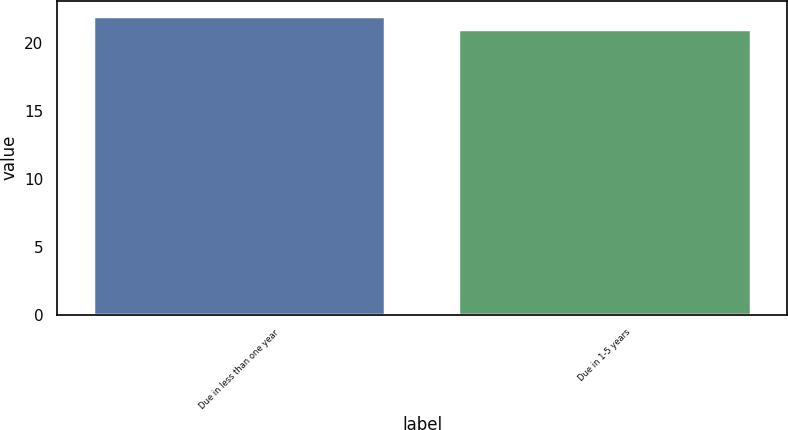<chart> <loc_0><loc_0><loc_500><loc_500><bar_chart><fcel>Due in less than one year<fcel>Due in 1-5 years<nl><fcel>22<fcel>21<nl></chart> 